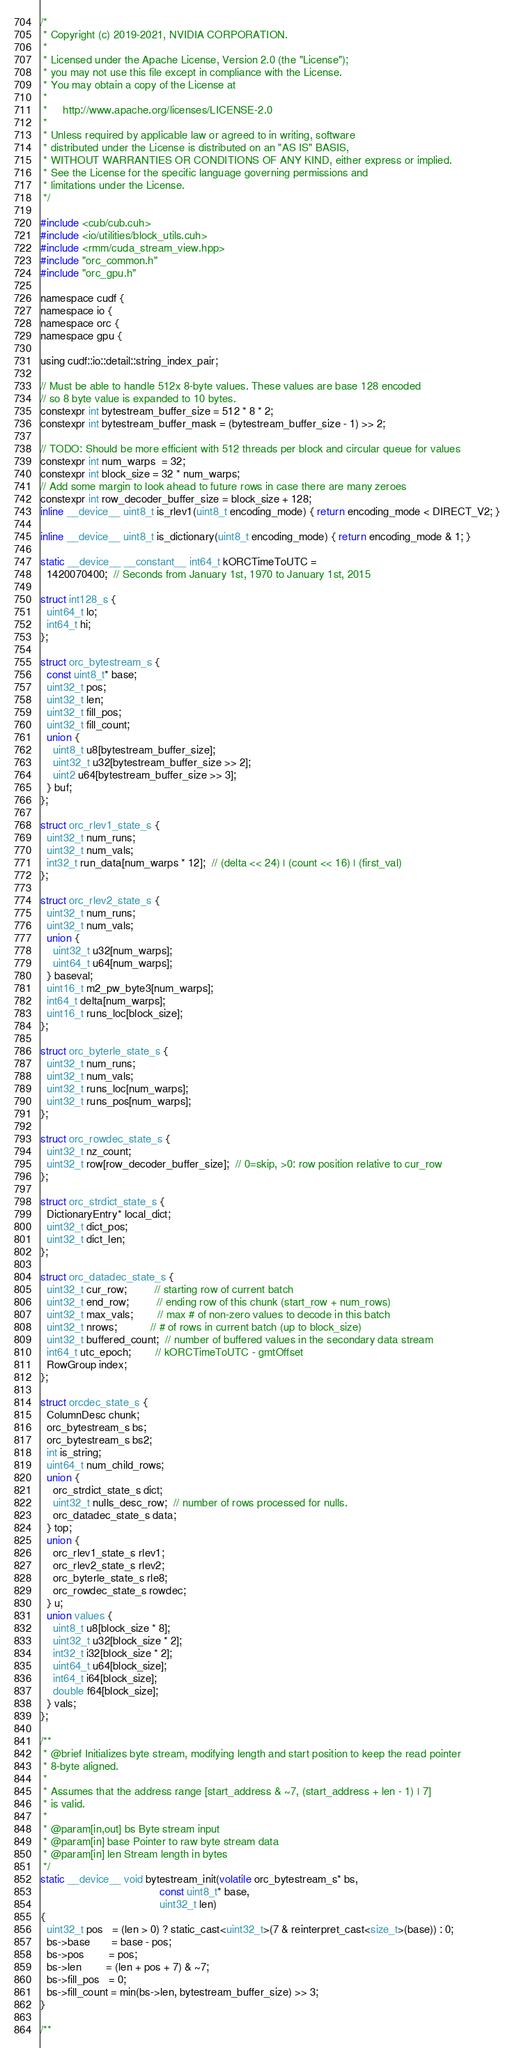<code> <loc_0><loc_0><loc_500><loc_500><_Cuda_>/*
 * Copyright (c) 2019-2021, NVIDIA CORPORATION.
 *
 * Licensed under the Apache License, Version 2.0 (the "License");
 * you may not use this file except in compliance with the License.
 * You may obtain a copy of the License at
 *
 *     http://www.apache.org/licenses/LICENSE-2.0
 *
 * Unless required by applicable law or agreed to in writing, software
 * distributed under the License is distributed on an "AS IS" BASIS,
 * WITHOUT WARRANTIES OR CONDITIONS OF ANY KIND, either express or implied.
 * See the License for the specific language governing permissions and
 * limitations under the License.
 */

#include <cub/cub.cuh>
#include <io/utilities/block_utils.cuh>
#include <rmm/cuda_stream_view.hpp>
#include "orc_common.h"
#include "orc_gpu.h"

namespace cudf {
namespace io {
namespace orc {
namespace gpu {

using cudf::io::detail::string_index_pair;

// Must be able to handle 512x 8-byte values. These values are base 128 encoded
// so 8 byte value is expanded to 10 bytes.
constexpr int bytestream_buffer_size = 512 * 8 * 2;
constexpr int bytestream_buffer_mask = (bytestream_buffer_size - 1) >> 2;

// TODO: Should be more efficient with 512 threads per block and circular queue for values
constexpr int num_warps  = 32;
constexpr int block_size = 32 * num_warps;
// Add some margin to look ahead to future rows in case there are many zeroes
constexpr int row_decoder_buffer_size = block_size + 128;
inline __device__ uint8_t is_rlev1(uint8_t encoding_mode) { return encoding_mode < DIRECT_V2; }

inline __device__ uint8_t is_dictionary(uint8_t encoding_mode) { return encoding_mode & 1; }

static __device__ __constant__ int64_t kORCTimeToUTC =
  1420070400;  // Seconds from January 1st, 1970 to January 1st, 2015

struct int128_s {
  uint64_t lo;
  int64_t hi;
};

struct orc_bytestream_s {
  const uint8_t* base;
  uint32_t pos;
  uint32_t len;
  uint32_t fill_pos;
  uint32_t fill_count;
  union {
    uint8_t u8[bytestream_buffer_size];
    uint32_t u32[bytestream_buffer_size >> 2];
    uint2 u64[bytestream_buffer_size >> 3];
  } buf;
};

struct orc_rlev1_state_s {
  uint32_t num_runs;
  uint32_t num_vals;
  int32_t run_data[num_warps * 12];  // (delta << 24) | (count << 16) | (first_val)
};

struct orc_rlev2_state_s {
  uint32_t num_runs;
  uint32_t num_vals;
  union {
    uint32_t u32[num_warps];
    uint64_t u64[num_warps];
  } baseval;
  uint16_t m2_pw_byte3[num_warps];
  int64_t delta[num_warps];
  uint16_t runs_loc[block_size];
};

struct orc_byterle_state_s {
  uint32_t num_runs;
  uint32_t num_vals;
  uint32_t runs_loc[num_warps];
  uint32_t runs_pos[num_warps];
};

struct orc_rowdec_state_s {
  uint32_t nz_count;
  uint32_t row[row_decoder_buffer_size];  // 0=skip, >0: row position relative to cur_row
};

struct orc_strdict_state_s {
  DictionaryEntry* local_dict;
  uint32_t dict_pos;
  uint32_t dict_len;
};

struct orc_datadec_state_s {
  uint32_t cur_row;         // starting row of current batch
  uint32_t end_row;         // ending row of this chunk (start_row + num_rows)
  uint32_t max_vals;        // max # of non-zero values to decode in this batch
  uint32_t nrows;           // # of rows in current batch (up to block_size)
  uint32_t buffered_count;  // number of buffered values in the secondary data stream
  int64_t utc_epoch;        // kORCTimeToUTC - gmtOffset
  RowGroup index;
};

struct orcdec_state_s {
  ColumnDesc chunk;
  orc_bytestream_s bs;
  orc_bytestream_s bs2;
  int is_string;
  uint64_t num_child_rows;
  union {
    orc_strdict_state_s dict;
    uint32_t nulls_desc_row;  // number of rows processed for nulls.
    orc_datadec_state_s data;
  } top;
  union {
    orc_rlev1_state_s rlev1;
    orc_rlev2_state_s rlev2;
    orc_byterle_state_s rle8;
    orc_rowdec_state_s rowdec;
  } u;
  union values {
    uint8_t u8[block_size * 8];
    uint32_t u32[block_size * 2];
    int32_t i32[block_size * 2];
    uint64_t u64[block_size];
    int64_t i64[block_size];
    double f64[block_size];
  } vals;
};

/**
 * @brief Initializes byte stream, modifying length and start position to keep the read pointer
 * 8-byte aligned.
 *
 * Assumes that the address range [start_address & ~7, (start_address + len - 1) | 7]
 * is valid.
 *
 * @param[in,out] bs Byte stream input
 * @param[in] base Pointer to raw byte stream data
 * @param[in] len Stream length in bytes
 */
static __device__ void bytestream_init(volatile orc_bytestream_s* bs,
                                       const uint8_t* base,
                                       uint32_t len)
{
  uint32_t pos   = (len > 0) ? static_cast<uint32_t>(7 & reinterpret_cast<size_t>(base)) : 0;
  bs->base       = base - pos;
  bs->pos        = pos;
  bs->len        = (len + pos + 7) & ~7;
  bs->fill_pos   = 0;
  bs->fill_count = min(bs->len, bytestream_buffer_size) >> 3;
}

/**</code> 